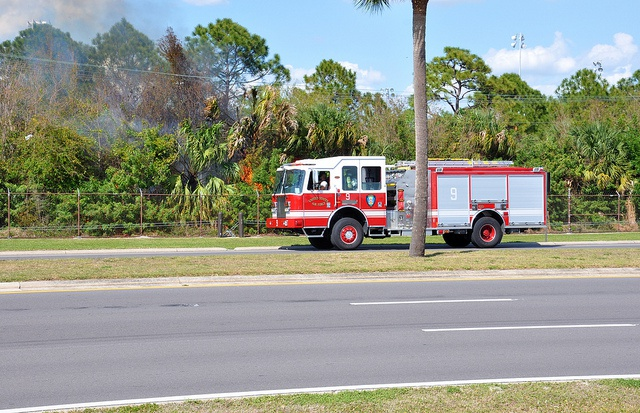Describe the objects in this image and their specific colors. I can see truck in lightgray, lavender, black, red, and lightblue tones and people in lightgray, black, maroon, white, and gray tones in this image. 